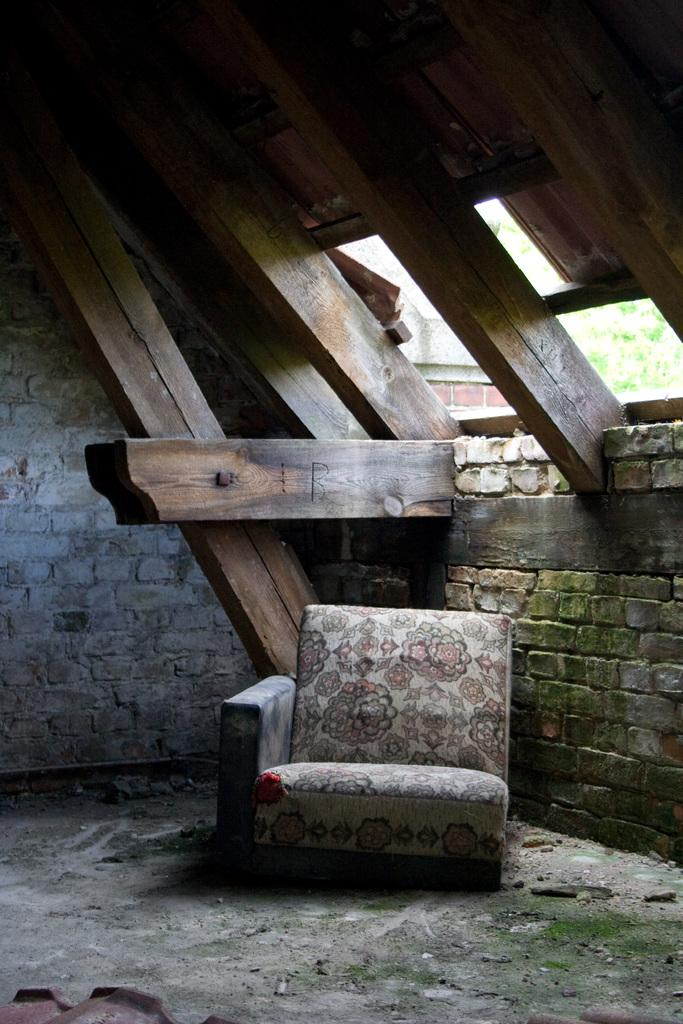What type of seating is present in the image? There is a sofa chair in the image. What material is used for the wall beside the sofa chair? The wall beside the sofa chair is made up of bricks. What type of roof is visible in the image? There is a wooden roof in the image. What can be seen in the background of the image? Trees and a wall are visible in the background of the image. How many zebras are standing on the wooden roof in the image? There are no zebras present in the image, and the wooden roof does not have any animals standing on it. 